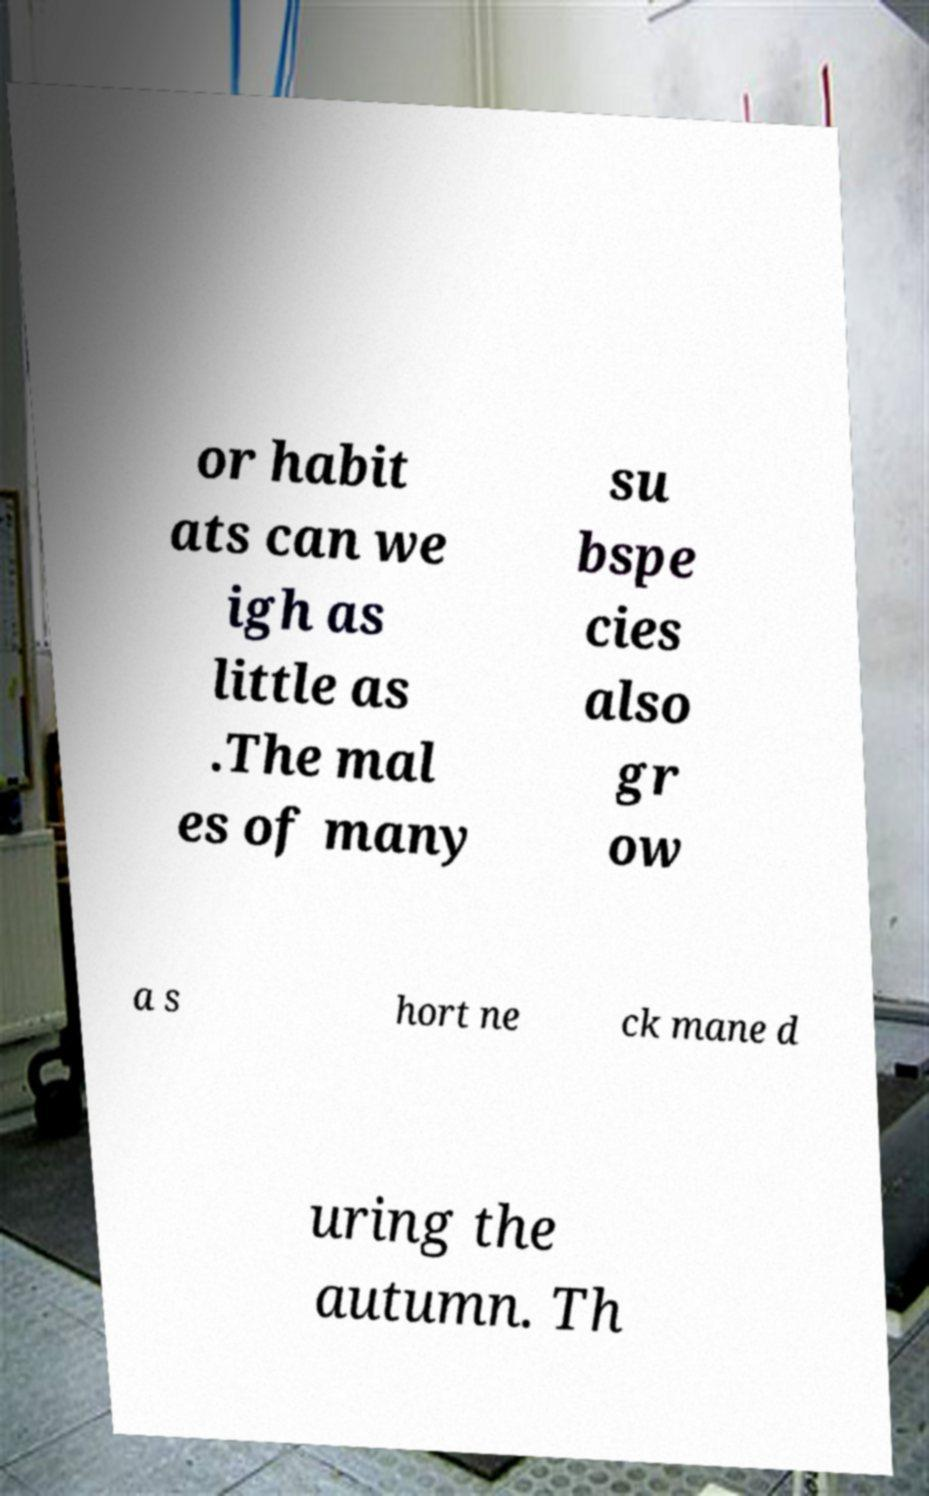Could you assist in decoding the text presented in this image and type it out clearly? or habit ats can we igh as little as .The mal es of many su bspe cies also gr ow a s hort ne ck mane d uring the autumn. Th 